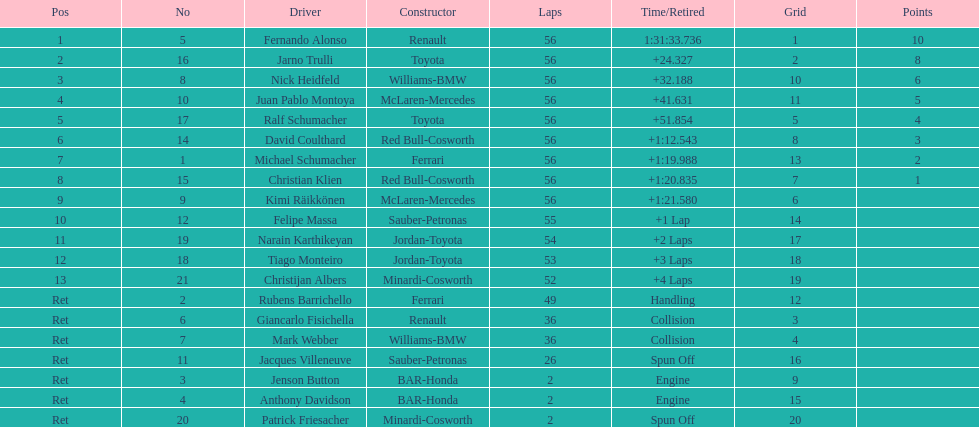What was the aggregate number of laps concluded by the 1st rank winner? 56. 